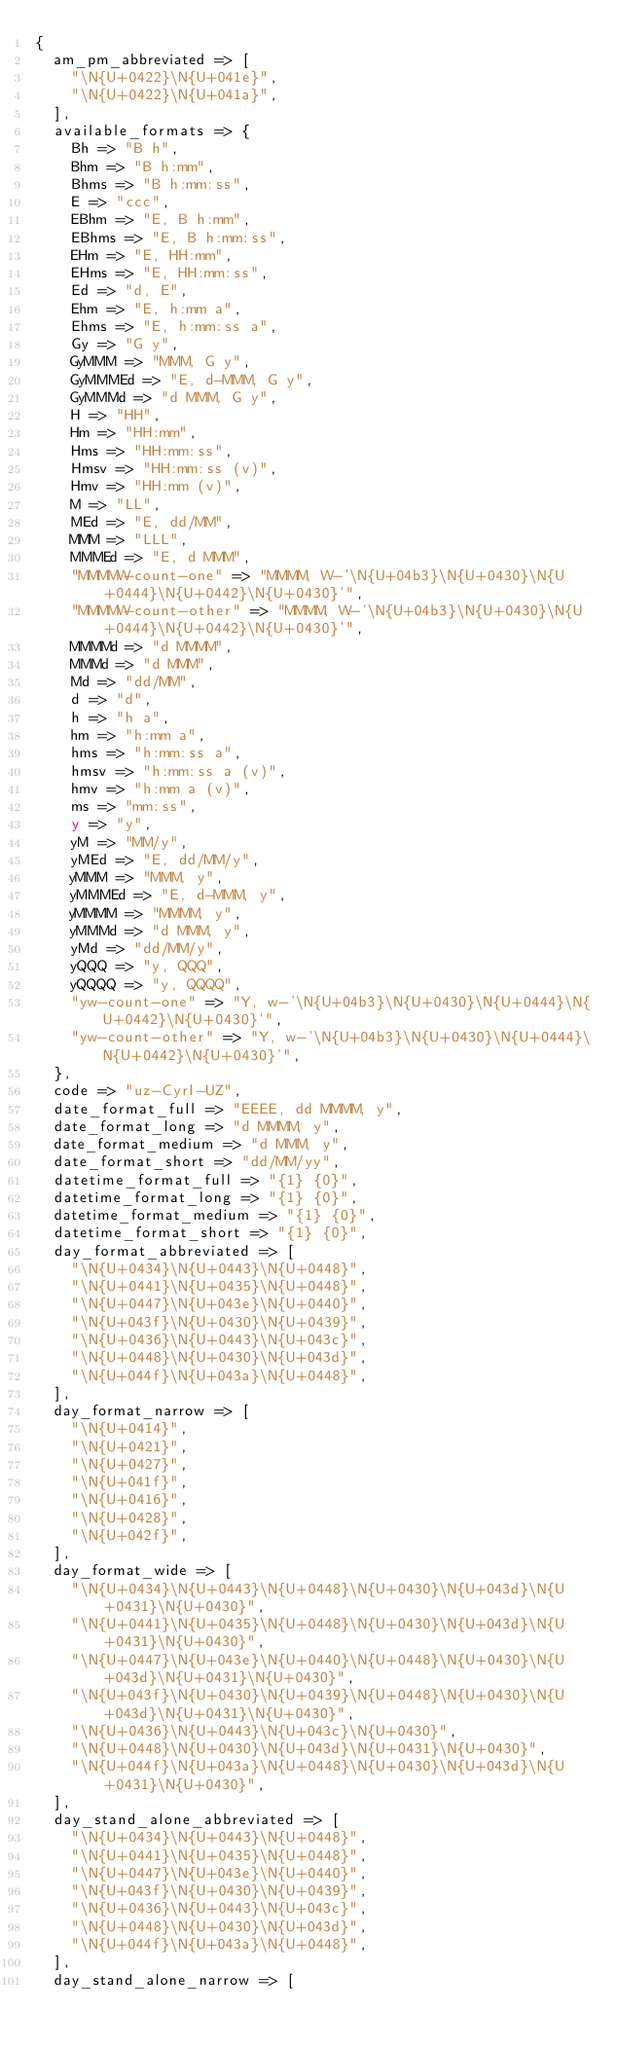Convert code to text. <code><loc_0><loc_0><loc_500><loc_500><_Perl_>{
  am_pm_abbreviated => [
    "\N{U+0422}\N{U+041e}",
    "\N{U+0422}\N{U+041a}",
  ],
  available_formats => {
    Bh => "B h",
    Bhm => "B h:mm",
    Bhms => "B h:mm:ss",
    E => "ccc",
    EBhm => "E, B h:mm",
    EBhms => "E, B h:mm:ss",
    EHm => "E, HH:mm",
    EHms => "E, HH:mm:ss",
    Ed => "d, E",
    Ehm => "E, h:mm a",
    Ehms => "E, h:mm:ss a",
    Gy => "G y",
    GyMMM => "MMM, G y",
    GyMMMEd => "E, d-MMM, G y",
    GyMMMd => "d MMM, G y",
    H => "HH",
    Hm => "HH:mm",
    Hms => "HH:mm:ss",
    Hmsv => "HH:mm:ss (v)",
    Hmv => "HH:mm (v)",
    M => "LL",
    MEd => "E, dd/MM",
    MMM => "LLL",
    MMMEd => "E, d MMM",
    "MMMMW-count-one" => "MMMM, W-'\N{U+04b3}\N{U+0430}\N{U+0444}\N{U+0442}\N{U+0430}'",
    "MMMMW-count-other" => "MMMM, W-'\N{U+04b3}\N{U+0430}\N{U+0444}\N{U+0442}\N{U+0430}'",
    MMMMd => "d MMMM",
    MMMd => "d MMM",
    Md => "dd/MM",
    d => "d",
    h => "h a",
    hm => "h:mm a",
    hms => "h:mm:ss a",
    hmsv => "h:mm:ss a (v)",
    hmv => "h:mm a (v)",
    ms => "mm:ss",
    y => "y",
    yM => "MM/y",
    yMEd => "E, dd/MM/y",
    yMMM => "MMM, y",
    yMMMEd => "E, d-MMM, y",
    yMMMM => "MMMM, y",
    yMMMd => "d MMM, y",
    yMd => "dd/MM/y",
    yQQQ => "y, QQQ",
    yQQQQ => "y, QQQQ",
    "yw-count-one" => "Y, w-'\N{U+04b3}\N{U+0430}\N{U+0444}\N{U+0442}\N{U+0430}'",
    "yw-count-other" => "Y, w-'\N{U+04b3}\N{U+0430}\N{U+0444}\N{U+0442}\N{U+0430}'",
  },
  code => "uz-Cyrl-UZ",
  date_format_full => "EEEE, dd MMMM, y",
  date_format_long => "d MMMM, y",
  date_format_medium => "d MMM, y",
  date_format_short => "dd/MM/yy",
  datetime_format_full => "{1} {0}",
  datetime_format_long => "{1} {0}",
  datetime_format_medium => "{1} {0}",
  datetime_format_short => "{1} {0}",
  day_format_abbreviated => [
    "\N{U+0434}\N{U+0443}\N{U+0448}",
    "\N{U+0441}\N{U+0435}\N{U+0448}",
    "\N{U+0447}\N{U+043e}\N{U+0440}",
    "\N{U+043f}\N{U+0430}\N{U+0439}",
    "\N{U+0436}\N{U+0443}\N{U+043c}",
    "\N{U+0448}\N{U+0430}\N{U+043d}",
    "\N{U+044f}\N{U+043a}\N{U+0448}",
  ],
  day_format_narrow => [
    "\N{U+0414}",
    "\N{U+0421}",
    "\N{U+0427}",
    "\N{U+041f}",
    "\N{U+0416}",
    "\N{U+0428}",
    "\N{U+042f}",
  ],
  day_format_wide => [
    "\N{U+0434}\N{U+0443}\N{U+0448}\N{U+0430}\N{U+043d}\N{U+0431}\N{U+0430}",
    "\N{U+0441}\N{U+0435}\N{U+0448}\N{U+0430}\N{U+043d}\N{U+0431}\N{U+0430}",
    "\N{U+0447}\N{U+043e}\N{U+0440}\N{U+0448}\N{U+0430}\N{U+043d}\N{U+0431}\N{U+0430}",
    "\N{U+043f}\N{U+0430}\N{U+0439}\N{U+0448}\N{U+0430}\N{U+043d}\N{U+0431}\N{U+0430}",
    "\N{U+0436}\N{U+0443}\N{U+043c}\N{U+0430}",
    "\N{U+0448}\N{U+0430}\N{U+043d}\N{U+0431}\N{U+0430}",
    "\N{U+044f}\N{U+043a}\N{U+0448}\N{U+0430}\N{U+043d}\N{U+0431}\N{U+0430}",
  ],
  day_stand_alone_abbreviated => [
    "\N{U+0434}\N{U+0443}\N{U+0448}",
    "\N{U+0441}\N{U+0435}\N{U+0448}",
    "\N{U+0447}\N{U+043e}\N{U+0440}",
    "\N{U+043f}\N{U+0430}\N{U+0439}",
    "\N{U+0436}\N{U+0443}\N{U+043c}",
    "\N{U+0448}\N{U+0430}\N{U+043d}",
    "\N{U+044f}\N{U+043a}\N{U+0448}",
  ],
  day_stand_alone_narrow => [</code> 